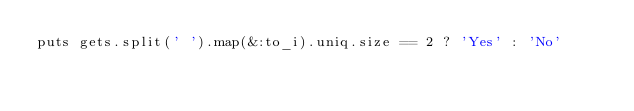<code> <loc_0><loc_0><loc_500><loc_500><_Ruby_>puts gets.split(' ').map(&:to_i).uniq.size == 2 ? 'Yes' : 'No'</code> 